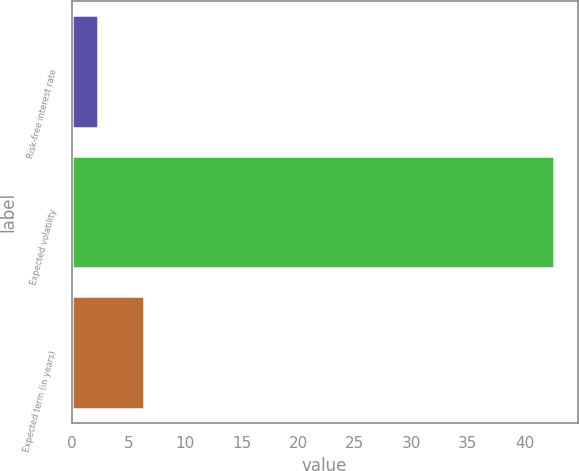<chart> <loc_0><loc_0><loc_500><loc_500><bar_chart><fcel>Risk-free interest rate<fcel>Expected volatility<fcel>Expected term (in years)<nl><fcel>2.36<fcel>42.57<fcel>6.38<nl></chart> 